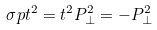<formula> <loc_0><loc_0><loc_500><loc_500>\sigma p t ^ { 2 } = t ^ { 2 } P ^ { 2 } _ { \perp } = - P ^ { 2 } _ { \perp }</formula> 